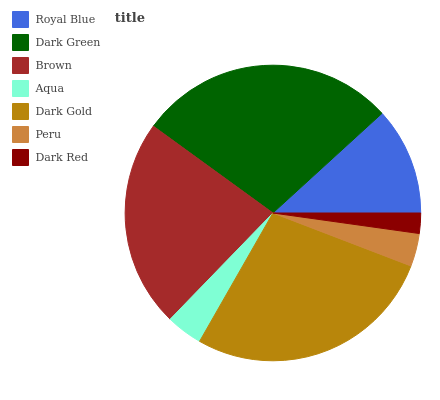Is Dark Red the minimum?
Answer yes or no. Yes. Is Dark Green the maximum?
Answer yes or no. Yes. Is Brown the minimum?
Answer yes or no. No. Is Brown the maximum?
Answer yes or no. No. Is Dark Green greater than Brown?
Answer yes or no. Yes. Is Brown less than Dark Green?
Answer yes or no. Yes. Is Brown greater than Dark Green?
Answer yes or no. No. Is Dark Green less than Brown?
Answer yes or no. No. Is Royal Blue the high median?
Answer yes or no. Yes. Is Royal Blue the low median?
Answer yes or no. Yes. Is Dark Gold the high median?
Answer yes or no. No. Is Aqua the low median?
Answer yes or no. No. 